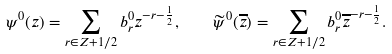Convert formula to latex. <formula><loc_0><loc_0><loc_500><loc_500>\psi ^ { 0 } ( z ) = \sum _ { r \in { Z } + 1 / 2 } b ^ { 0 } _ { r } z ^ { - r - \frac { 1 } { 2 } } , \quad \widetilde { \psi } ^ { 0 } ( \overline { z } ) = \sum _ { r \in { Z } + 1 / 2 } b ^ { 0 } _ { r } \overline { z } ^ { - r - \frac { 1 } { 2 } } .</formula> 